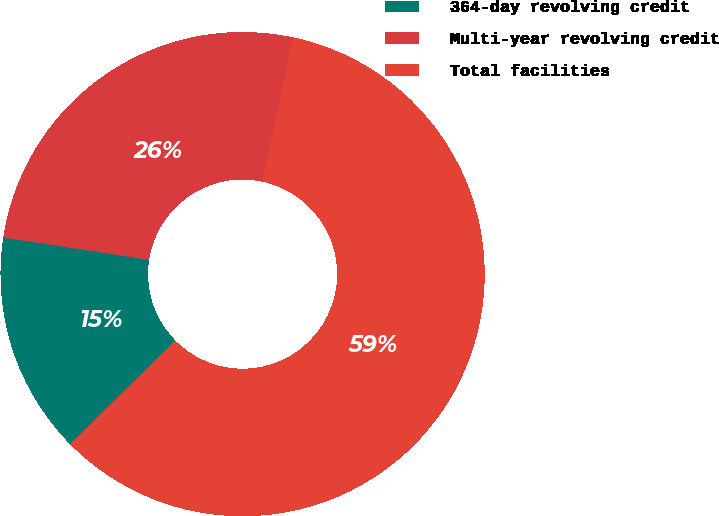Convert chart. <chart><loc_0><loc_0><loc_500><loc_500><pie_chart><fcel>364-day revolving credit<fcel>Multi-year revolving credit<fcel>Total facilities<nl><fcel>14.81%<fcel>25.93%<fcel>59.26%<nl></chart> 